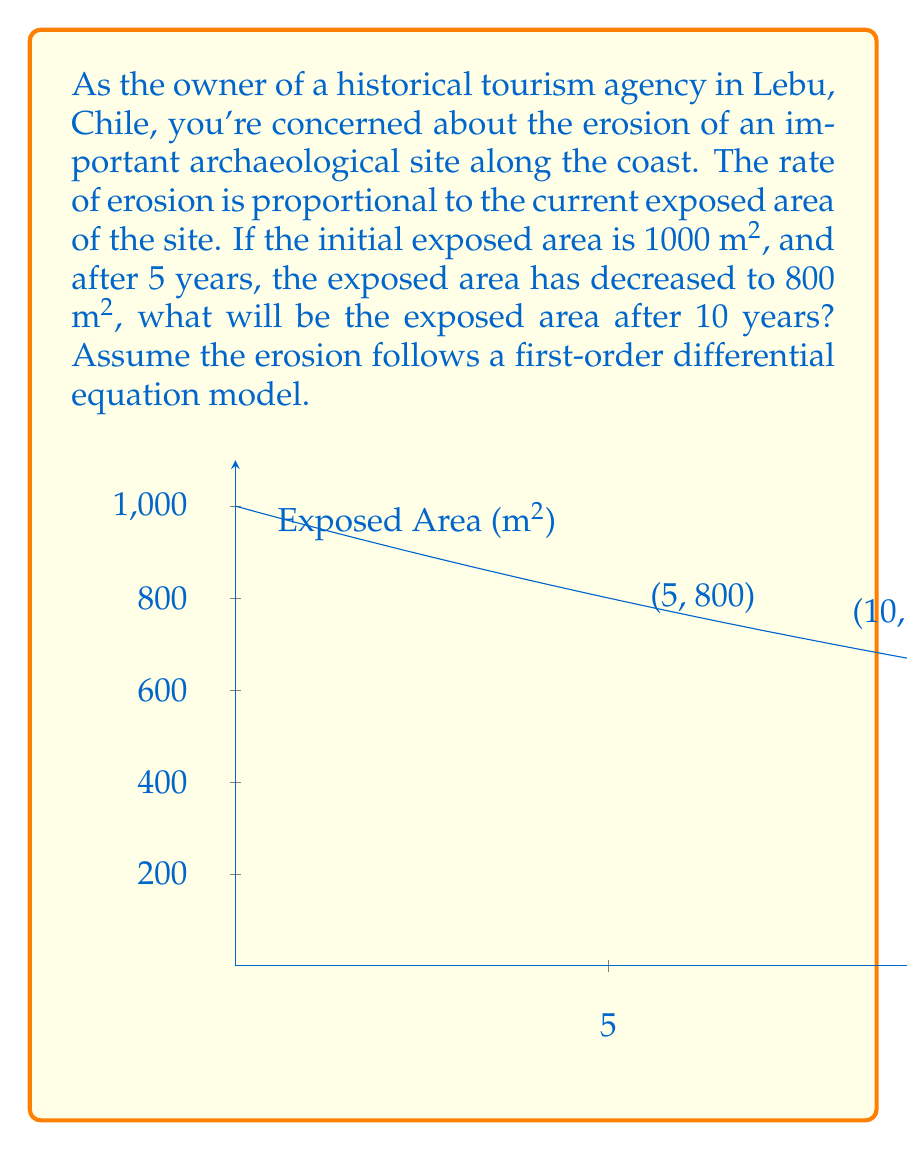Teach me how to tackle this problem. Let's approach this step-by-step:

1) Let $A(t)$ be the exposed area at time $t$ in years. We're given that the rate of change is proportional to the current area:

   $$\frac{dA}{dt} = -kA$$

   where $k$ is a positive constant (negative sign because the area is decreasing).

2) The solution to this differential equation is:

   $$A(t) = A_0e^{-kt}$$

   where $A_0$ is the initial area.

3) We're given that $A_0 = 1000$ m² and $A(5) = 800$ m². Let's use these to find $k$:

   $$800 = 1000e^{-5k}$$

4) Solving for $k$:

   $$e^{-5k} = 0.8$$
   $$-5k = \ln(0.8)$$
   $$k = -\frac{\ln(0.8)}{5} \approx 0.0446$$

5) Now we have our complete model:

   $$A(t) = 1000e^{-0.0446t}$$

6) To find the area after 10 years, we calculate $A(10)$:

   $$A(10) = 1000e^{-0.0446 \cdot 10} \approx 640.71$$

Therefore, after 10 years, the exposed area will be approximately 640.71 m².
Answer: 640.71 m² 